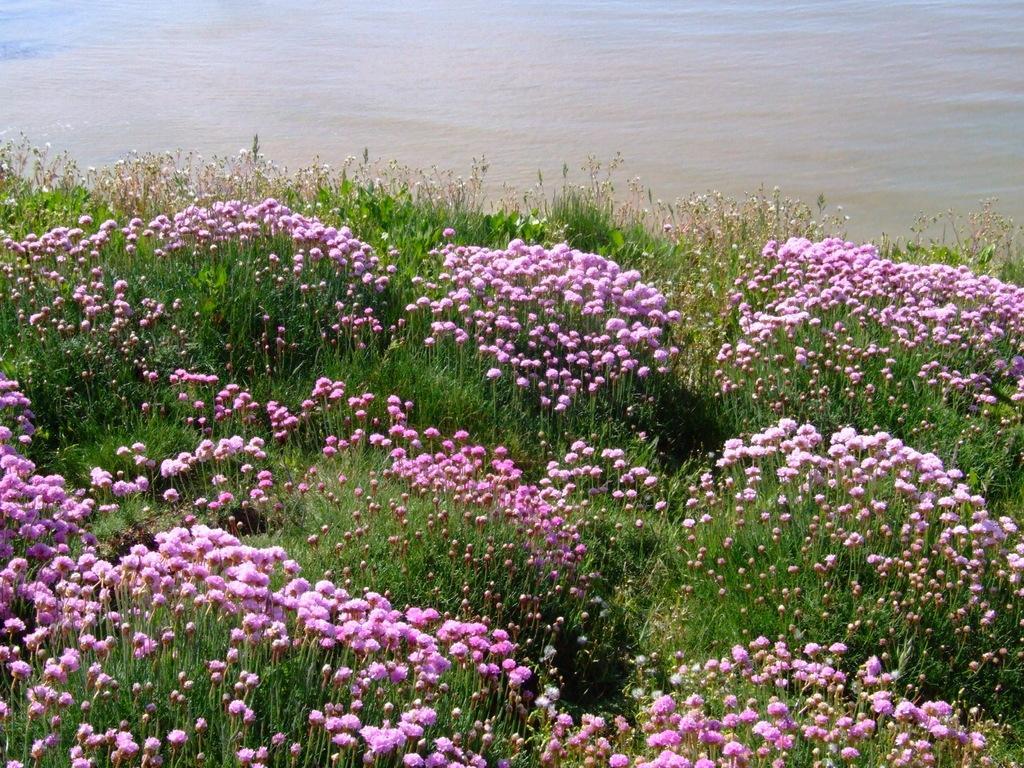Could you give a brief overview of what you see in this image? In this image we can see many flowers to the plants. We can see the water at the top of the image. 